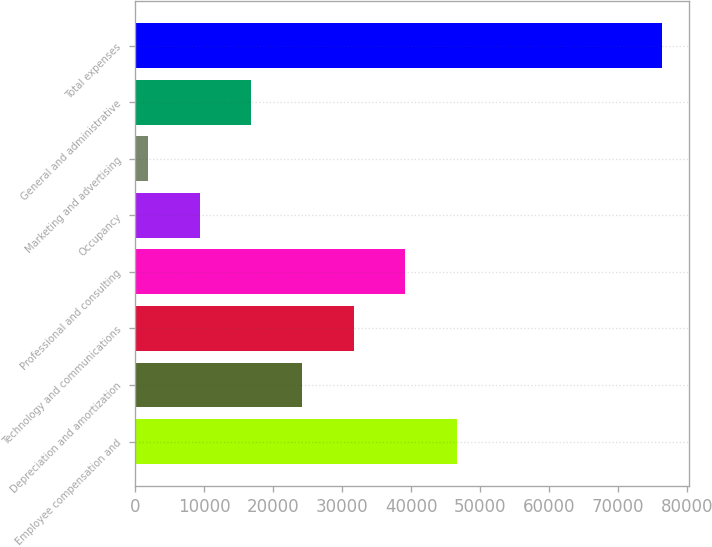<chart> <loc_0><loc_0><loc_500><loc_500><bar_chart><fcel>Employee compensation and<fcel>Depreciation and amortization<fcel>Technology and communications<fcel>Professional and consulting<fcel>Occupancy<fcel>Marketing and advertising<fcel>General and administrative<fcel>Total expenses<nl><fcel>46597.2<fcel>24251.1<fcel>31699.8<fcel>39148.5<fcel>9353.7<fcel>1905<fcel>16802.4<fcel>76392<nl></chart> 